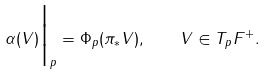<formula> <loc_0><loc_0><loc_500><loc_500>\alpha ( V ) \Big | _ { p } = \Phi _ { p } ( \pi _ { * } V ) , \quad V \in T _ { p } F ^ { + } .</formula> 